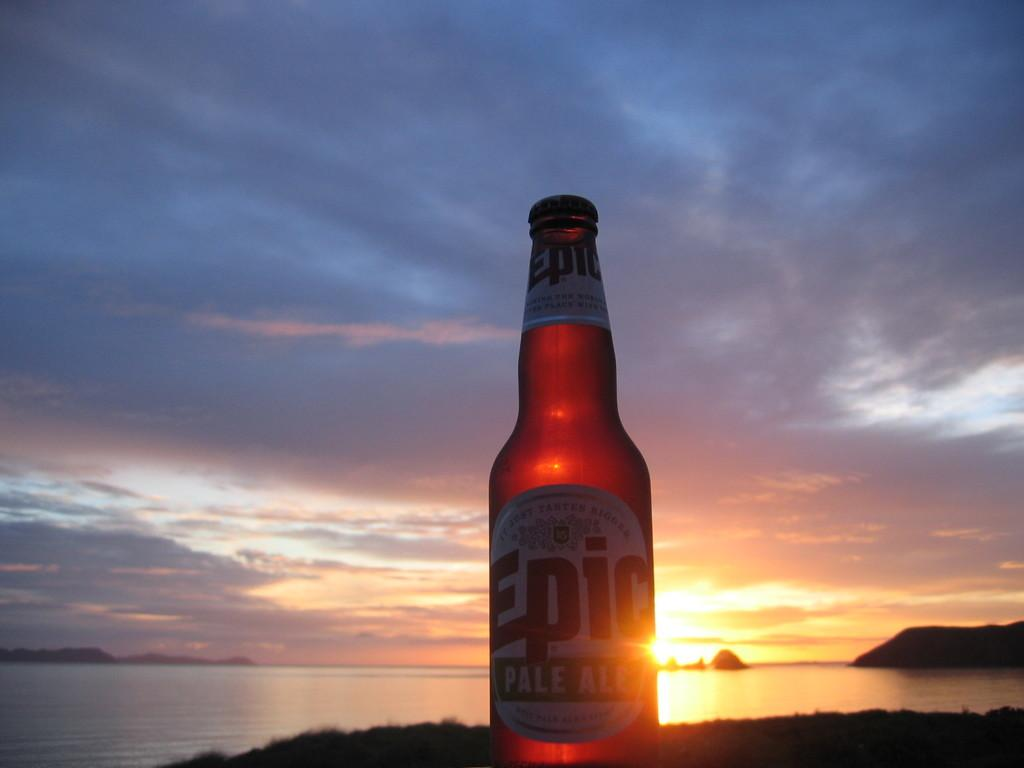Provide a one-sentence caption for the provided image. An unopened bottle of Epic pale ale next to a body of water with the sun shining through it. 